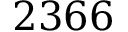Convert formula to latex. <formula><loc_0><loc_0><loc_500><loc_500>2 3 6 6</formula> 